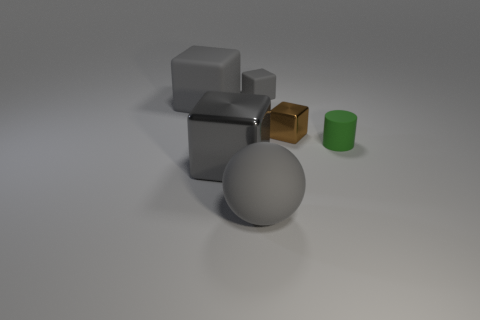Subtract all yellow cylinders. How many gray blocks are left? 3 Subtract 1 cubes. How many cubes are left? 3 Add 3 gray shiny objects. How many objects exist? 9 Subtract all cylinders. How many objects are left? 5 Subtract all big metal things. Subtract all small shiny cubes. How many objects are left? 4 Add 6 spheres. How many spheres are left? 7 Add 6 large yellow metal objects. How many large yellow metal objects exist? 6 Subtract 1 green cylinders. How many objects are left? 5 